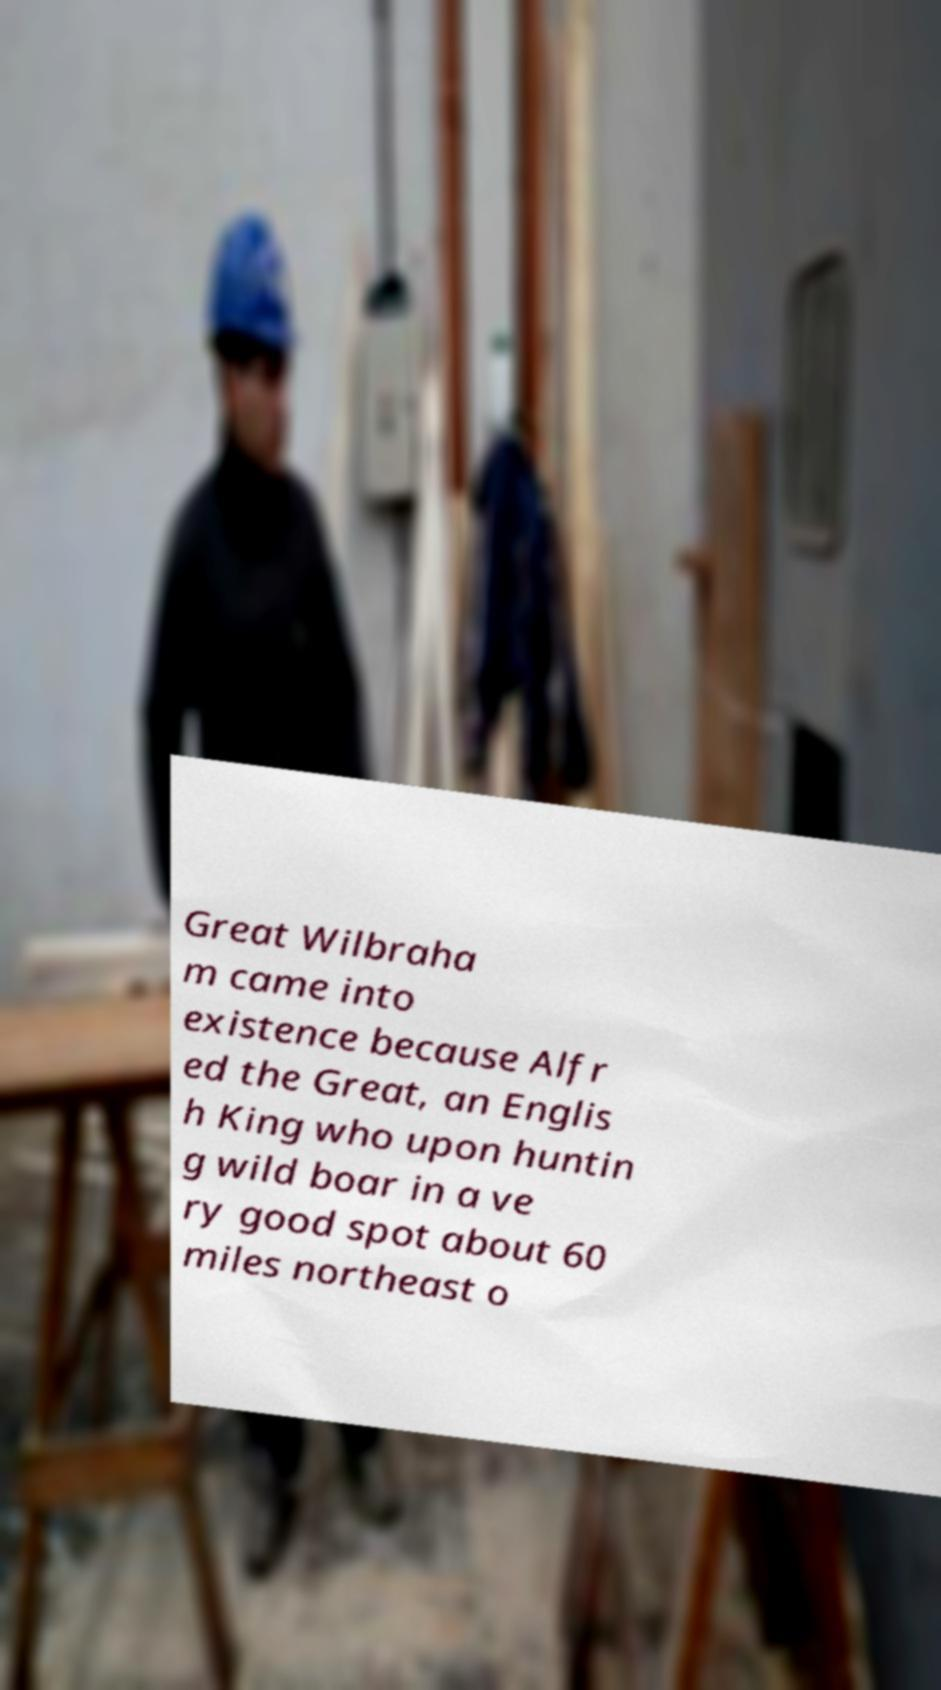Please identify and transcribe the text found in this image. Great Wilbraha m came into existence because Alfr ed the Great, an Englis h King who upon huntin g wild boar in a ve ry good spot about 60 miles northeast o 